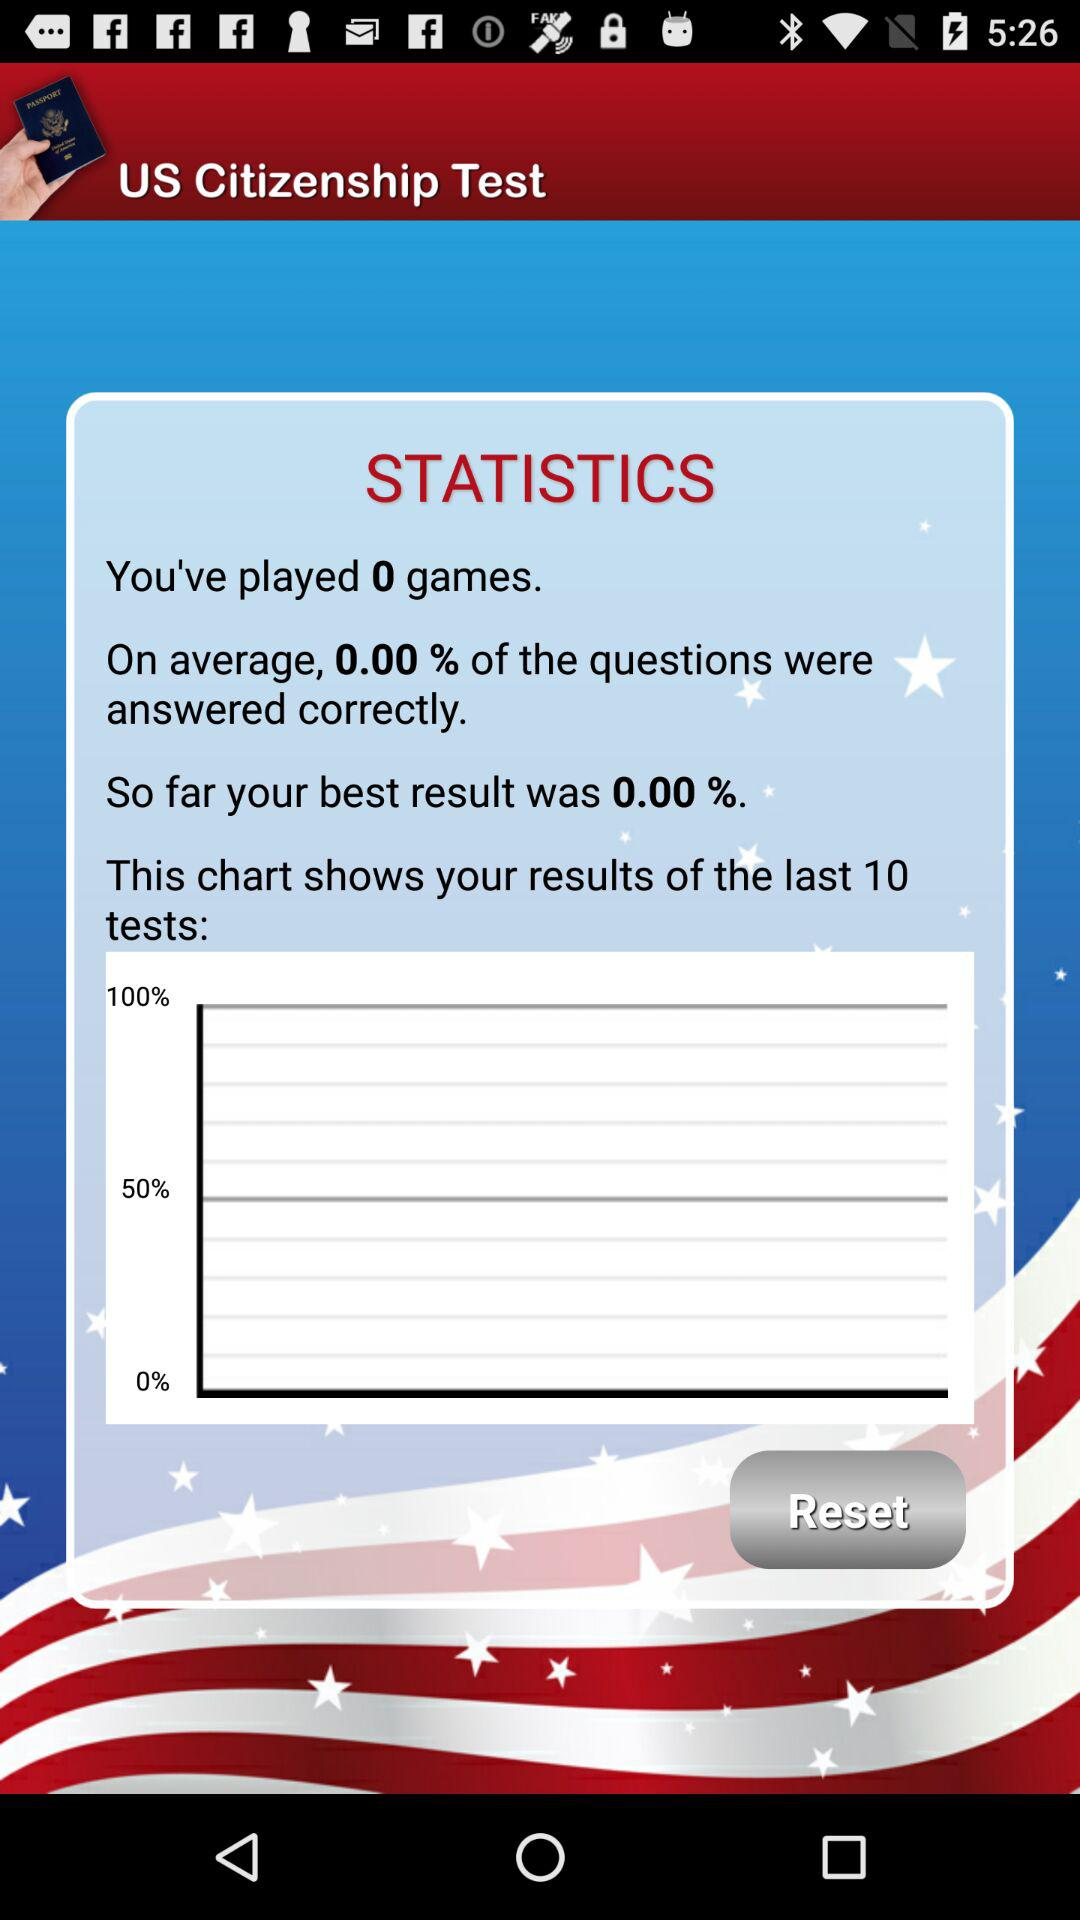How many previous test results does the chart shows? The chart shows 10 previous results. 